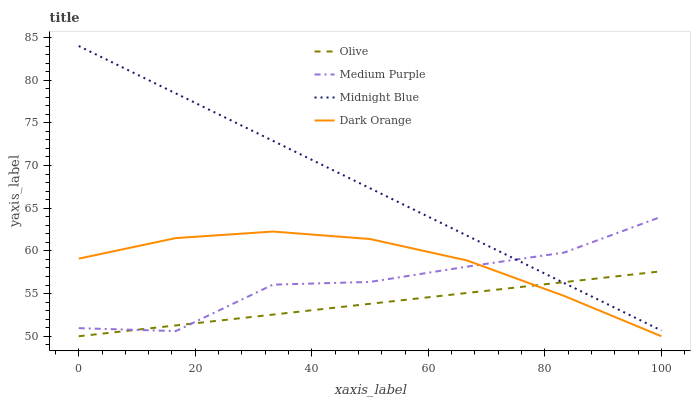Does Olive have the minimum area under the curve?
Answer yes or no. Yes. Does Midnight Blue have the maximum area under the curve?
Answer yes or no. Yes. Does Medium Purple have the minimum area under the curve?
Answer yes or no. No. Does Medium Purple have the maximum area under the curve?
Answer yes or no. No. Is Olive the smoothest?
Answer yes or no. Yes. Is Medium Purple the roughest?
Answer yes or no. Yes. Is Midnight Blue the smoothest?
Answer yes or no. No. Is Midnight Blue the roughest?
Answer yes or no. No. Does Medium Purple have the lowest value?
Answer yes or no. No. Does Midnight Blue have the highest value?
Answer yes or no. Yes. Does Medium Purple have the highest value?
Answer yes or no. No. Is Dark Orange less than Midnight Blue?
Answer yes or no. Yes. Is Midnight Blue greater than Dark Orange?
Answer yes or no. Yes. Does Olive intersect Midnight Blue?
Answer yes or no. Yes. Is Olive less than Midnight Blue?
Answer yes or no. No. Is Olive greater than Midnight Blue?
Answer yes or no. No. Does Dark Orange intersect Midnight Blue?
Answer yes or no. No. 